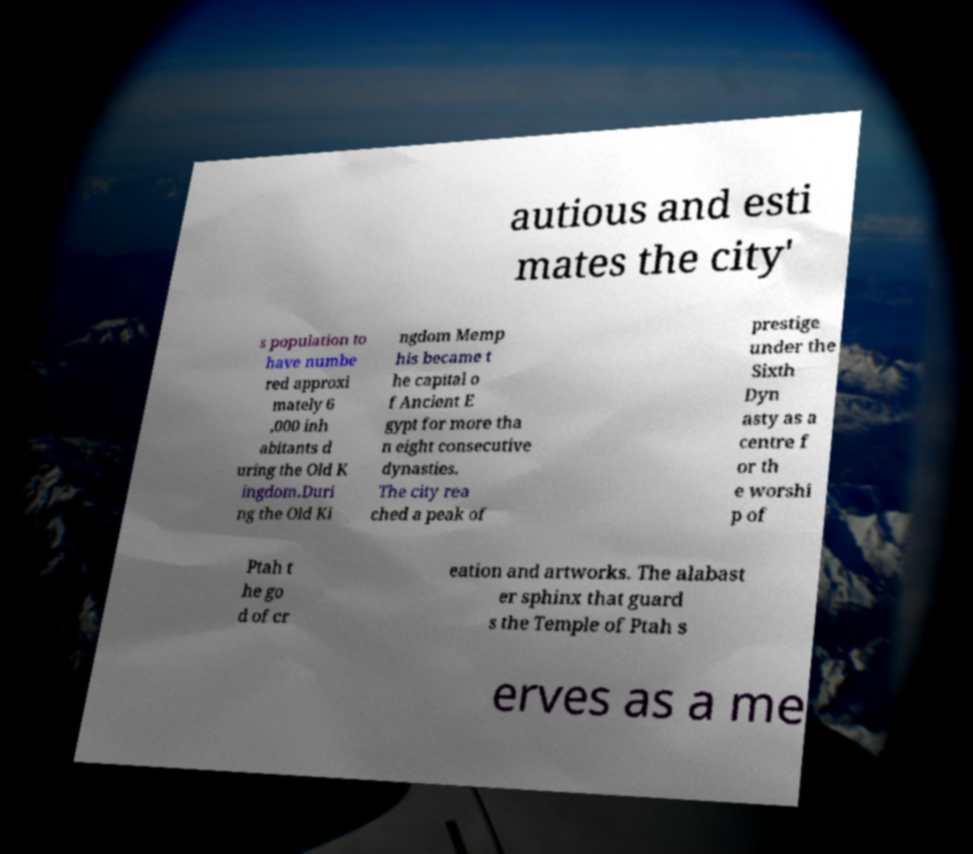I need the written content from this picture converted into text. Can you do that? autious and esti mates the city' s population to have numbe red approxi mately 6 ,000 inh abitants d uring the Old K ingdom.Duri ng the Old Ki ngdom Memp his became t he capital o f Ancient E gypt for more tha n eight consecutive dynasties. The city rea ched a peak of prestige under the Sixth Dyn asty as a centre f or th e worshi p of Ptah t he go d of cr eation and artworks. The alabast er sphinx that guard s the Temple of Ptah s erves as a me 